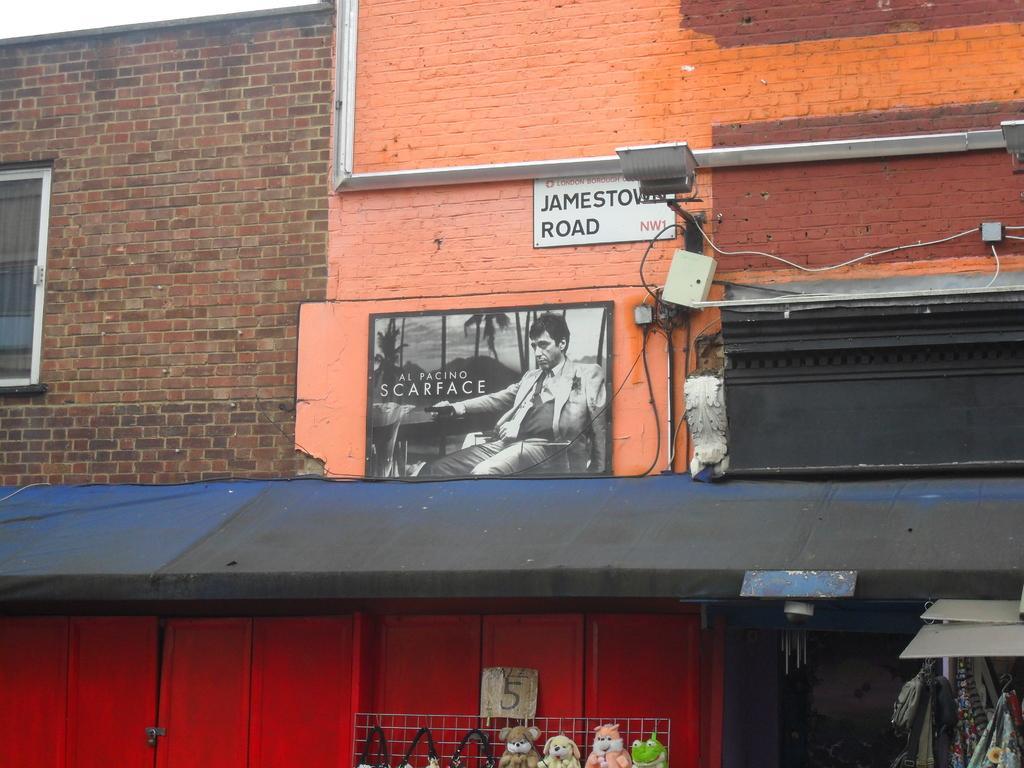Describe this image in one or two sentences. There is a building and there is a picture, a light and a board are attached to the wall of the building and below that there is a store with some materials and toys. On the left side there is a window. 